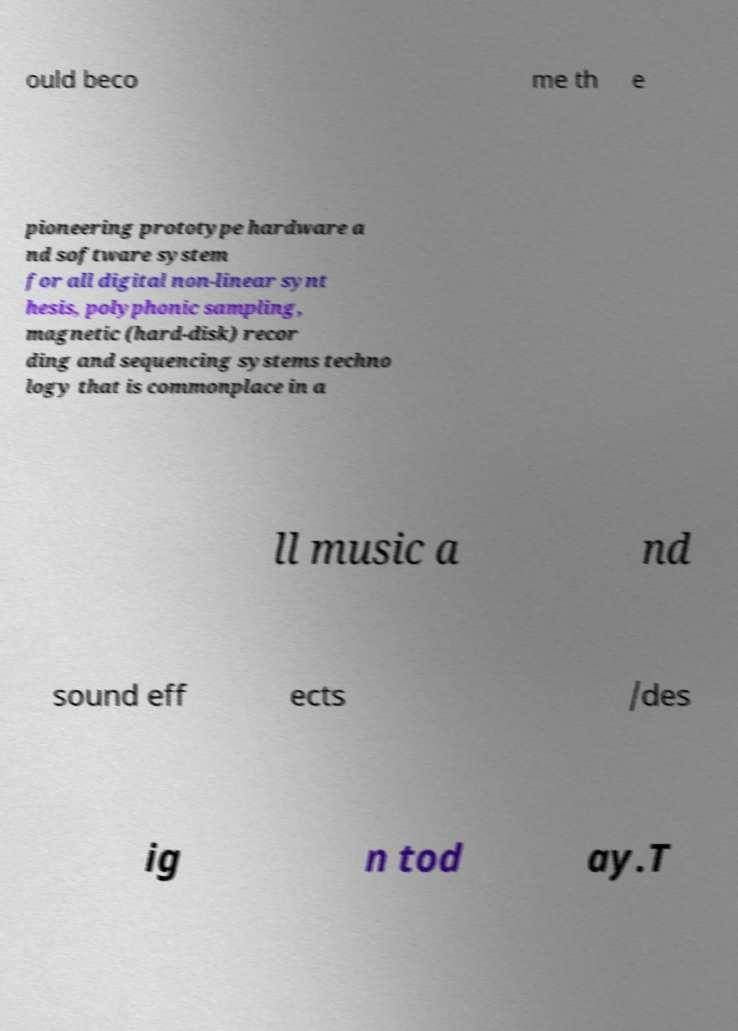For documentation purposes, I need the text within this image transcribed. Could you provide that? ould beco me th e pioneering prototype hardware a nd software system for all digital non-linear synt hesis, polyphonic sampling, magnetic (hard-disk) recor ding and sequencing systems techno logy that is commonplace in a ll music a nd sound eff ects /des ig n tod ay.T 